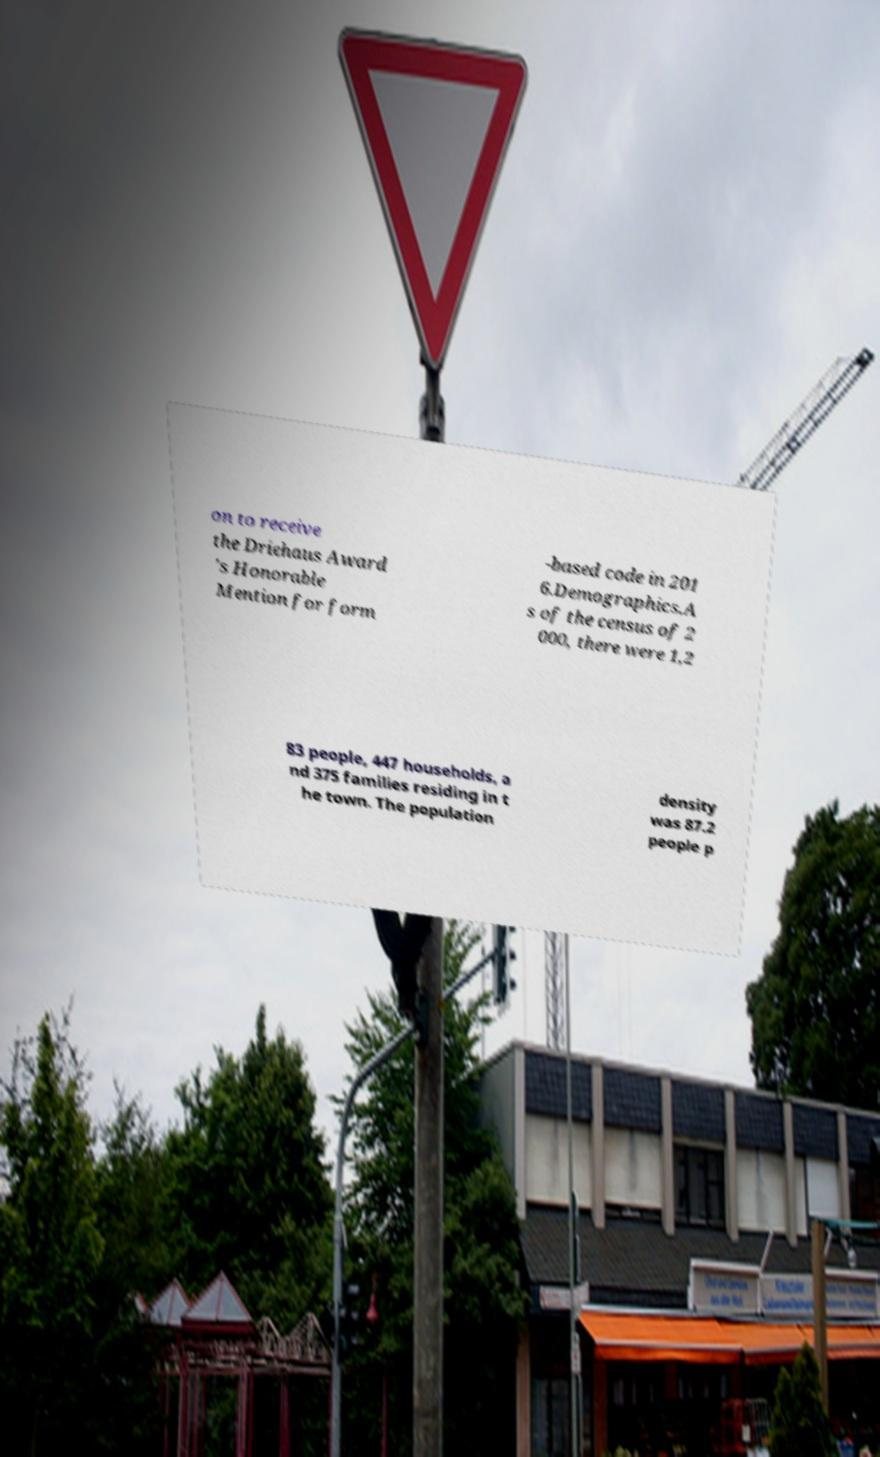There's text embedded in this image that I need extracted. Can you transcribe it verbatim? on to receive the Driehaus Award 's Honorable Mention for form -based code in 201 6.Demographics.A s of the census of 2 000, there were 1,2 83 people, 447 households, a nd 375 families residing in t he town. The population density was 87.2 people p 